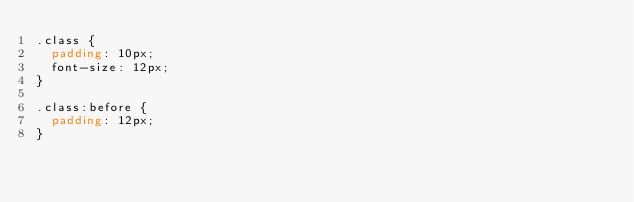Convert code to text. <code><loc_0><loc_0><loc_500><loc_500><_CSS_>.class {
  padding: 10px;
  font-size: 12px;
}

.class:before {
  padding: 12px;
}
</code> 